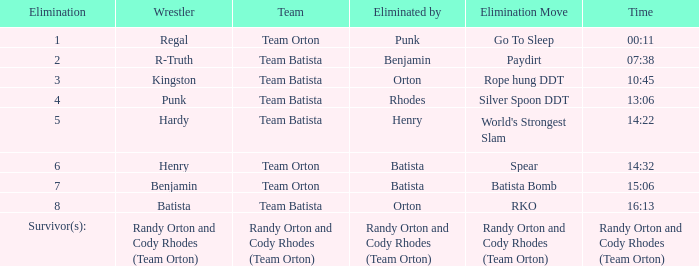Which elimination move did batista use against team orton for the 7th elimination? Batista Bomb. 